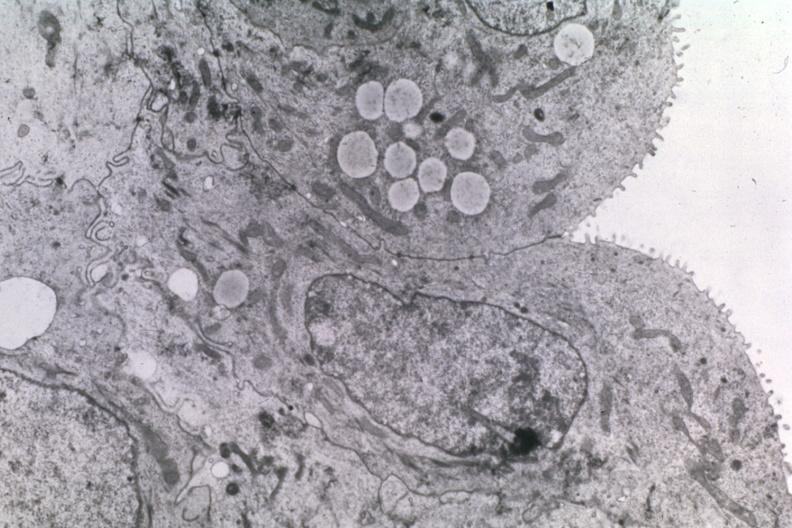does polyarteritis nodosa show dr garcia tumors 20?
Answer the question using a single word or phrase. No 